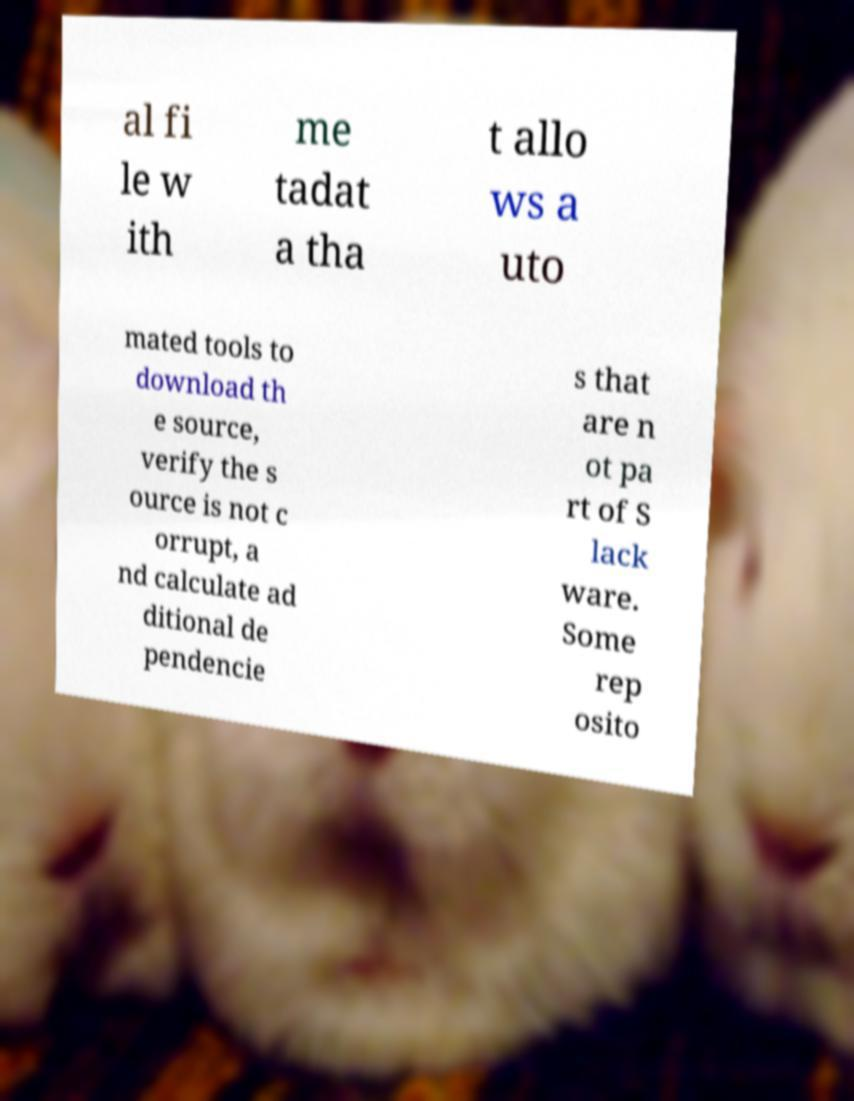What messages or text are displayed in this image? I need them in a readable, typed format. al fi le w ith me tadat a tha t allo ws a uto mated tools to download th e source, verify the s ource is not c orrupt, a nd calculate ad ditional de pendencie s that are n ot pa rt of S lack ware. Some rep osito 